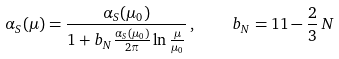Convert formula to latex. <formula><loc_0><loc_0><loc_500><loc_500>\alpha _ { S } ( \mu ) = \frac { \alpha _ { S } ( \mu _ { 0 } ) } { 1 + b _ { N } \frac { \alpha _ { S } ( \mu _ { 0 } ) } { 2 \pi } \ln \frac { \mu } { \mu _ { 0 } } } \, , \quad b _ { N } = 1 1 - \frac { 2 } { 3 } \, N</formula> 